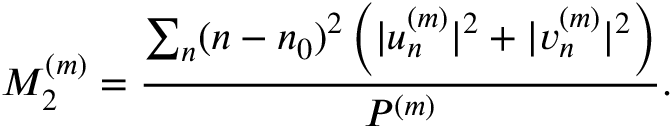<formula> <loc_0><loc_0><loc_500><loc_500>M _ { 2 } ^ { ( m ) } = \frac { \sum _ { n } ( n - n _ { 0 } ) ^ { 2 } \left ( | u _ { n } ^ { ( m ) } | ^ { 2 } + | v _ { n } ^ { ( m ) } | ^ { 2 } \right ) } { P ^ { ( m ) } } .</formula> 